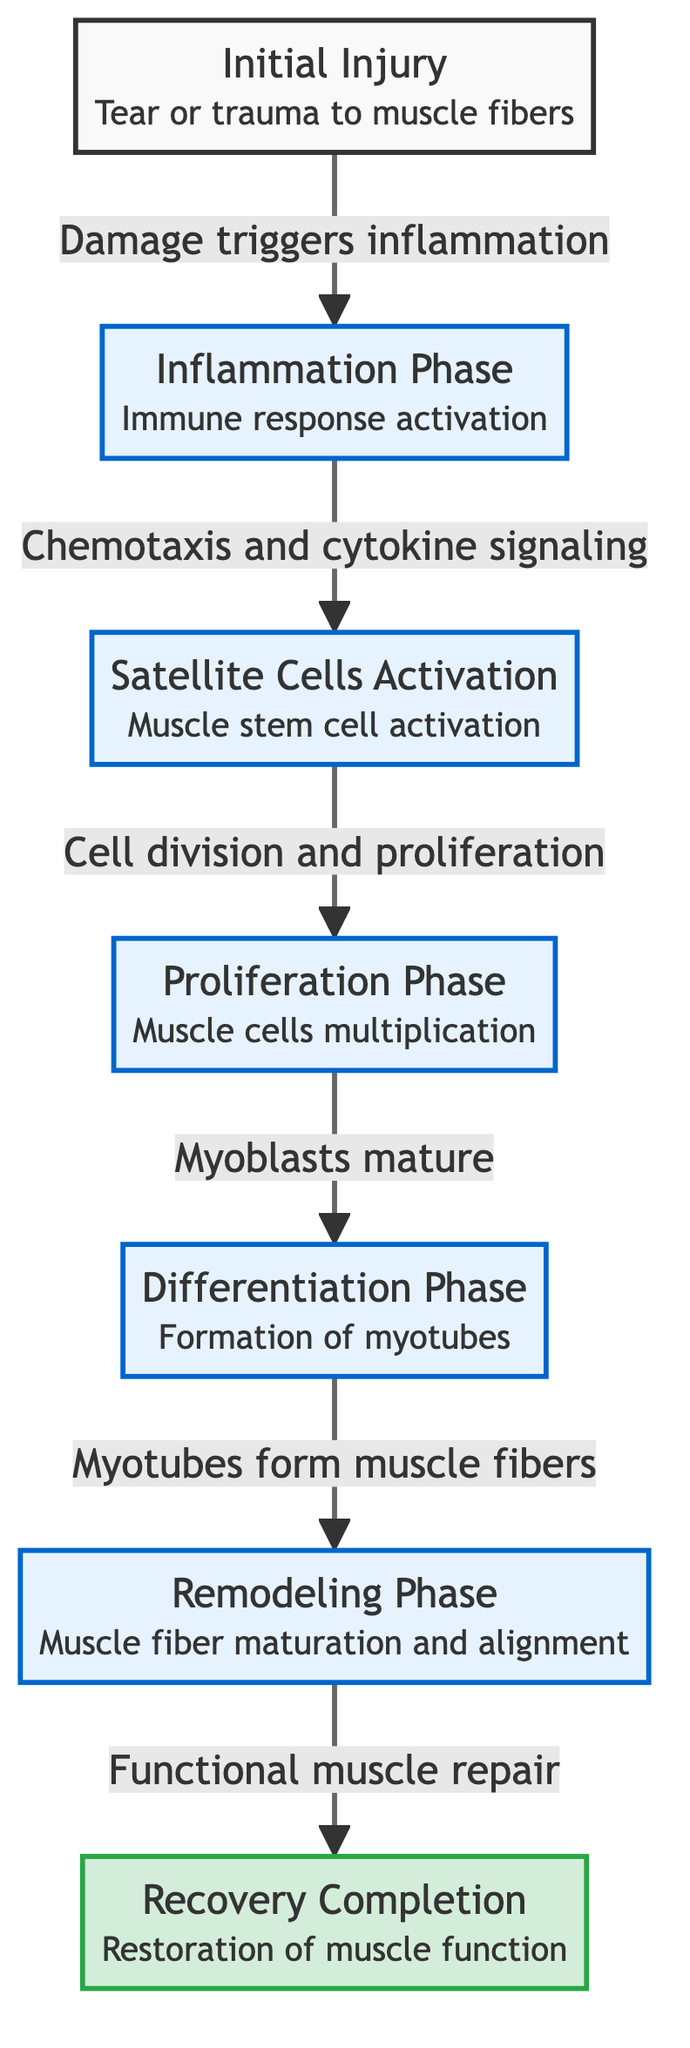What triggers the inflammation phase? The diagram shows an arrow from "Initial Injury" to "Inflammation Phase" with the label "Damage triggers inflammation," indicating that the initial injury leads to the inflammation phase.
Answer: Damage What is the role of satellite cells in muscle recovery? According to the diagram, after the inflammation phase, satellite cells are activated, which leads to cell division and proliferation. This suggests that satellite cells play a crucial role in starting the muscle recovery process, particularly during the activation stage.
Answer: Activation How many distinct phases are labeled in the diagram? The diagram has six labeled phases: Inflammation Phase, Satellite Cells Activation, Proliferation Phase, Differentiation Phase, Remodeling Phase, and Recovery Completion. Counting these gives a total of six distinct phases depicted in the diagram.
Answer: 6 Which phase involves the formation of myotubes? The flowchart indicates that the "Differentiation Phase" is specifically labeled as the stage where "Myotubes form muscle fibers." This title directly identifies this phase as the one involving myotube formation.
Answer: Differentiation Phase What is the final outcome of the muscle recovery process? The last node in the flowchart is "Recovery Completion," which is labeled as "Restoration of muscle function." This clearly indicates the final outcome of the entire recovery process.
Answer: Restoration of muscle function How do muscle cells multiply during recovery? The diagram illustrates that after satellite cell activation, there is a transition to the "Proliferation Phase," which is specifically labeled as "Muscle cells multiplication." This explains that muscle cells multiply during this phase as a key part of recovery.
Answer: Muscle cells multiplication What is the first step after initial injury according to the flowchart? The diagram shows that immediately after the "Initial Injury," the first step in the recovery process is the onset of the "Inflammation Phase." This indicates it is the very first step following an injury.
Answer: Inflammation Phase Which phase follows the activation of satellite cells? The arrow leading from "Satellite Cells Activation" points to the "Proliferation Phase." This signifies that the activation of satellite cells is directly followed by the proliferation of muscle cells.
Answer: Proliferation Phase 